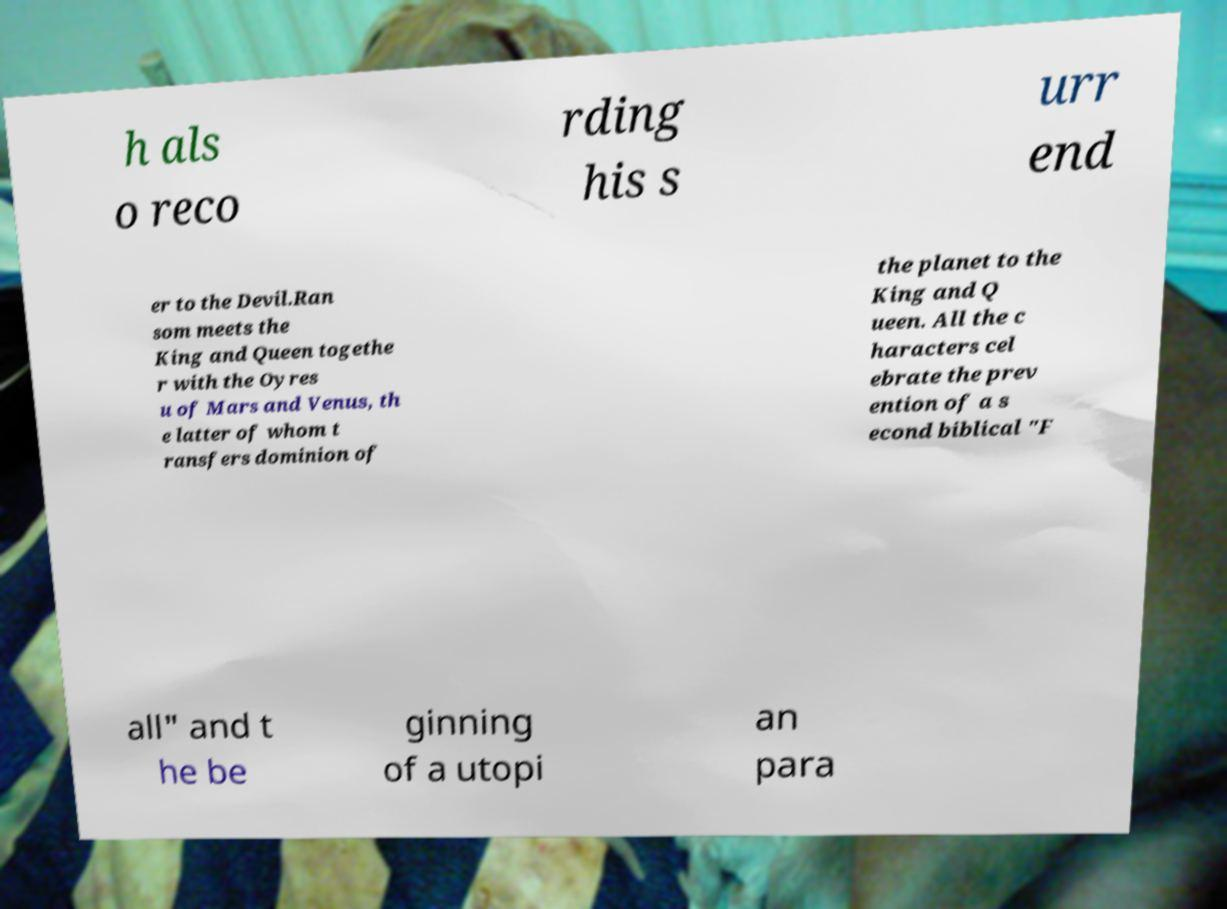Can you read and provide the text displayed in the image?This photo seems to have some interesting text. Can you extract and type it out for me? h als o reco rding his s urr end er to the Devil.Ran som meets the King and Queen togethe r with the Oyres u of Mars and Venus, th e latter of whom t ransfers dominion of the planet to the King and Q ueen. All the c haracters cel ebrate the prev ention of a s econd biblical "F all" and t he be ginning of a utopi an para 